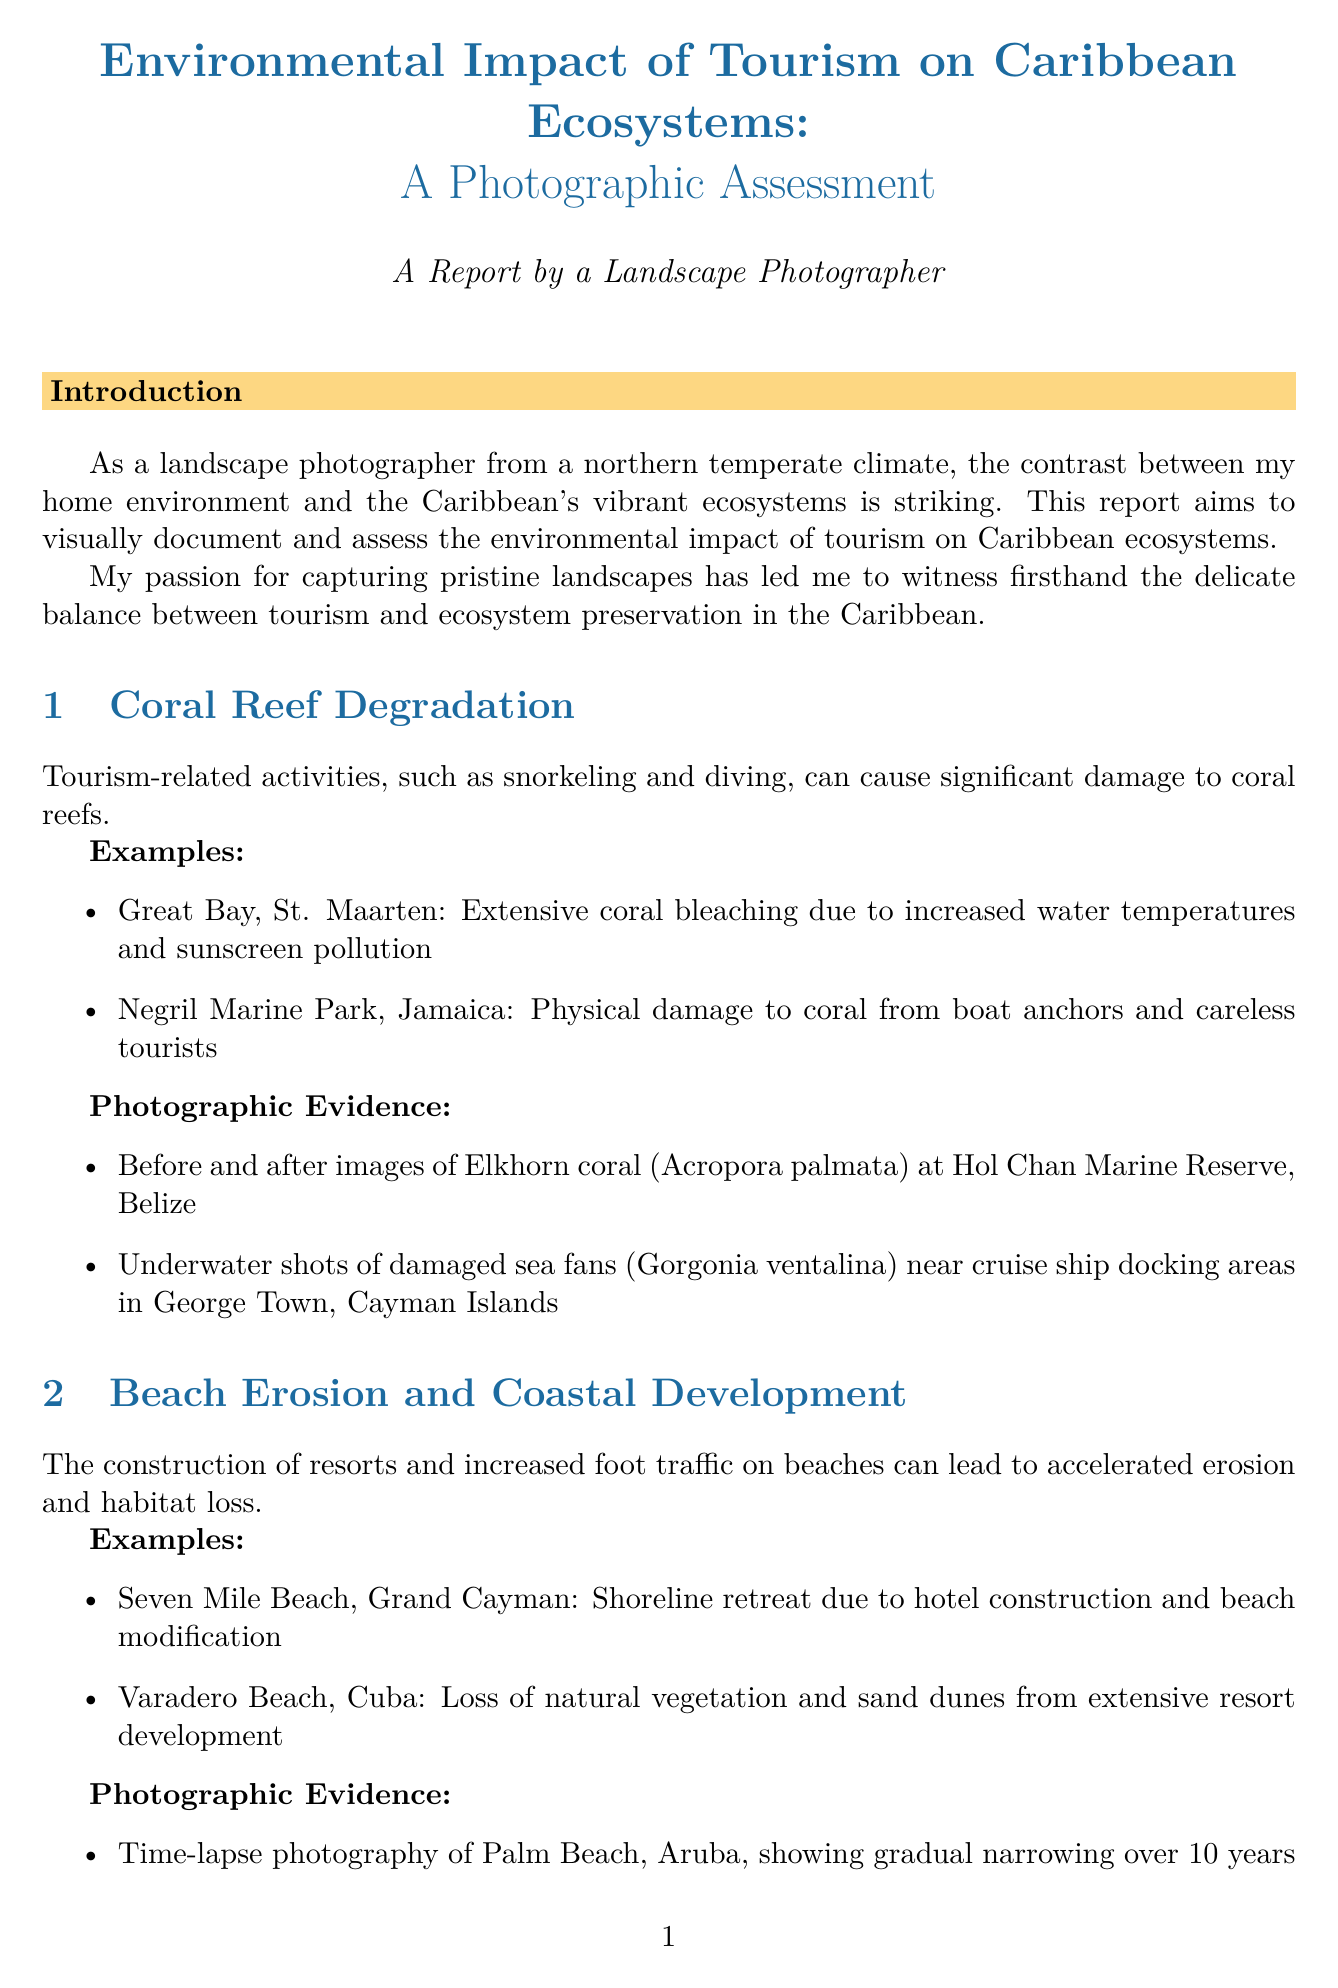What is the report's title? The report's title is explicitly stated at the beginning as "Environmental Impact of Tourism on Caribbean Ecosystems: A Photographic Assessment."
Answer: Environmental Impact of Tourism on Caribbean Ecosystems: A Photographic Assessment Which Caribbean location experienced coral bleaching? Coral bleaching is specifically referenced in the example of "Great Bay, St. Maarten."
Answer: Great Bay, St. Maarten What ecological issue is associated with Seven Mile Beach? The issue mentioned in the section about Seven Mile Beach is "shoreline retreat due to hotel construction and beach modification."
Answer: Shoreline retreat How long is the time-lapse photography for Palm Beach's erosion? The time-lapse photography duration is specified as "10 years" showcasing gradual narrowing.
Answer: 10 years What are the two types of pollution mentioned in the report? The report mentions "algal blooms due to nutrient runoff" and "plastic waste accumulation" as types of water pollution.
Answer: Algal blooms and plastic waste What technique was used for capturing coral reef images? The document indicates that "underwater housing for Canon EOS R5" was used to capture coral reef images.
Answer: Underwater housing for Canon EOS R5 Which animal's nesting behavior was compared in the report? The report discusses "sea turtles nesting on undisturbed vs. heavily visited beaches" indicating the subject of comparison.
Answer: Sea turtles What is one of the recommendations for sustainable tourism? The report suggests to "implement stricter regulations on coastal development" as part of its recommendations.
Answer: Implement stricter regulations on coastal development 